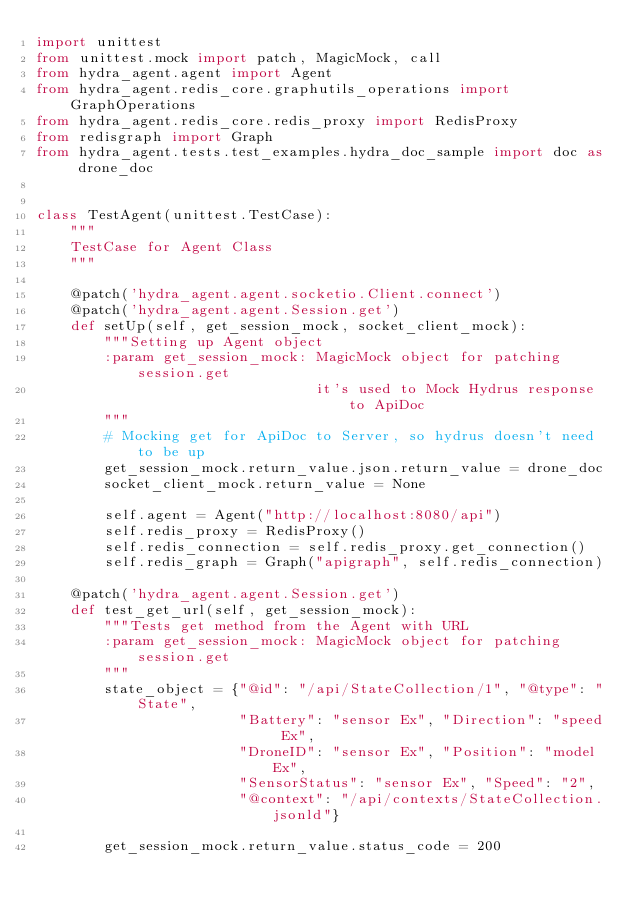<code> <loc_0><loc_0><loc_500><loc_500><_Python_>import unittest
from unittest.mock import patch, MagicMock, call
from hydra_agent.agent import Agent
from hydra_agent.redis_core.graphutils_operations import GraphOperations
from hydra_agent.redis_core.redis_proxy import RedisProxy
from redisgraph import Graph
from hydra_agent.tests.test_examples.hydra_doc_sample import doc as drone_doc


class TestAgent(unittest.TestCase):
    """
    TestCase for Agent Class
    """

    @patch('hydra_agent.agent.socketio.Client.connect')
    @patch('hydra_agent.agent.Session.get')
    def setUp(self, get_session_mock, socket_client_mock):
        """Setting up Agent object
        :param get_session_mock: MagicMock object for patching session.get
                                 it's used to Mock Hydrus response to ApiDoc
        """
        # Mocking get for ApiDoc to Server, so hydrus doesn't need to be up
        get_session_mock.return_value.json.return_value = drone_doc
        socket_client_mock.return_value = None

        self.agent = Agent("http://localhost:8080/api")
        self.redis_proxy = RedisProxy()
        self.redis_connection = self.redis_proxy.get_connection()
        self.redis_graph = Graph("apigraph", self.redis_connection)

    @patch('hydra_agent.agent.Session.get')
    def test_get_url(self, get_session_mock):
        """Tests get method from the Agent with URL
        :param get_session_mock: MagicMock object for patching session.get
        """
        state_object = {"@id": "/api/StateCollection/1", "@type": "State",
                        "Battery": "sensor Ex", "Direction": "speed Ex",
                        "DroneID": "sensor Ex", "Position": "model Ex",
                        "SensorStatus": "sensor Ex", "Speed": "2",
                        "@context": "/api/contexts/StateCollection.jsonld"}

        get_session_mock.return_value.status_code = 200</code> 